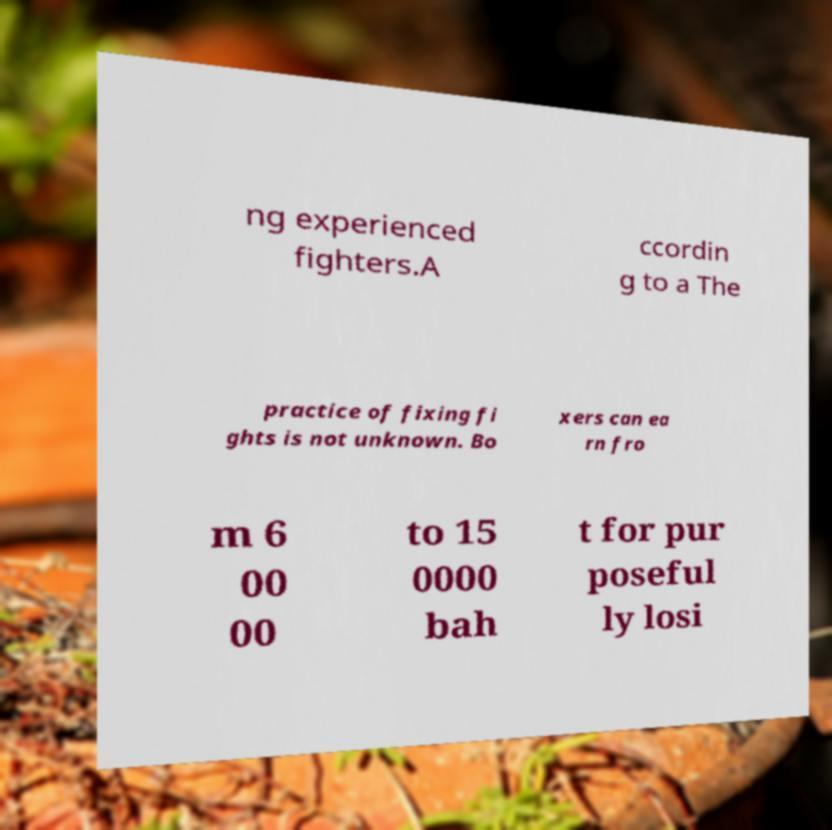Could you extract and type out the text from this image? ng experienced fighters.A ccordin g to a The practice of fixing fi ghts is not unknown. Bo xers can ea rn fro m 6 00 00 to 15 0000 bah t for pur poseful ly losi 